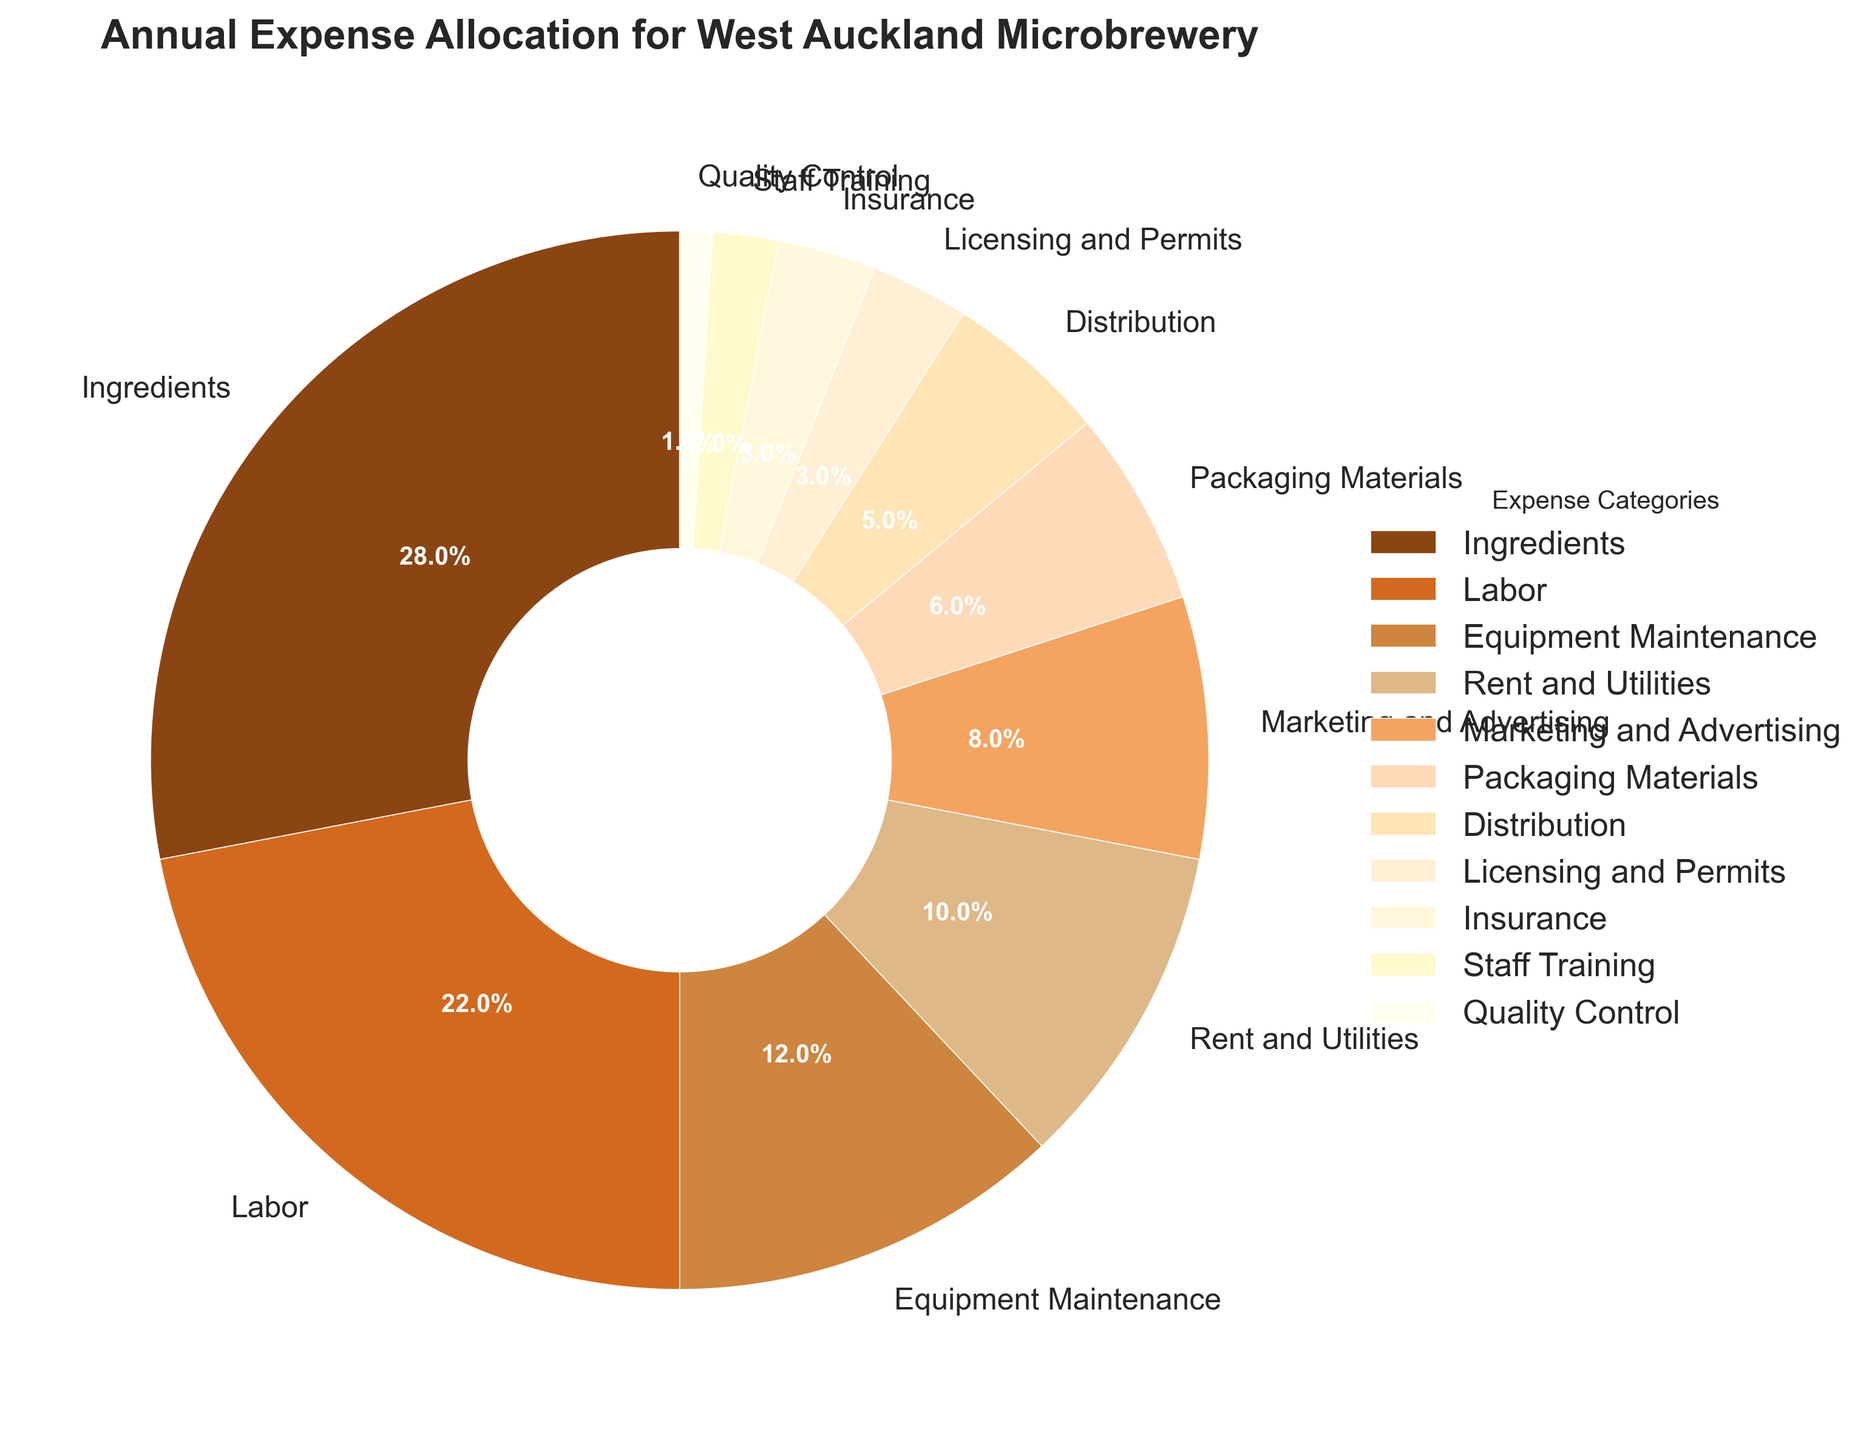Which expense category has the highest percentage? We look at the pie chart and identify that the largest slice corresponds to "Ingredients"
Answer: Ingredients What is the combined percentage of Rent and Utilities, and Equipment Maintenance? From the pie chart, we see Rent and Utilities is 10% and Equipment Maintenance is 12%. Adding these together gives 10% + 12% = 22%
Answer: 22% Which expense categories together make up more than 50% of the total expenses? By examining the chart, we find that Ingredients (28%) + Labor (22%) = 50%. Adding Equipment Maintenance (12%) takes it to 62%, which is over 50%.
Answer: Ingredients, Labor, Equipment Maintenance Does Marketing and Advertising or Packaging Materials account for a higher percentage of expenses? By looking at the labels, Marketing and Advertising is 8% while Packaging Materials is 6%. Clearly, 8% > 6%.
Answer: Marketing and Advertising What is the difference in percentage between Labor and Quality Control expenses? Labor expense is 22% and Quality Control is 1%. The difference is 22% - 1% = 21%
Answer: 21% Identify the expense category with the lowest percentage. The smallest slice in the pie chart corresponds to Quality Control with 1%
Answer: Quality Control What is the combined percentage of Distribution, Licensing and Permits, and Insurance? From the chart, Distribution is 5%, Licensing and Permits is 3%, and Insurance is 3%. Adding these gives 5% + 3% + 3% = 11%
Answer: 11% Which accounts for a higher percentage: Insurance or Staff Training? From the pie chart, Insurance is 3% whereas Staff Training is 2%. Clearly, 3% > 2%
Answer: Insurance List all expense categories that have a percentage less than 5%. The categories with slices less than 5% are Licensing and Permits (3%), Insurance (3%), Staff Training (2%), and Quality Control (1%)
Answer: Licensing and Permits, Insurance, Staff Training, Quality Control 